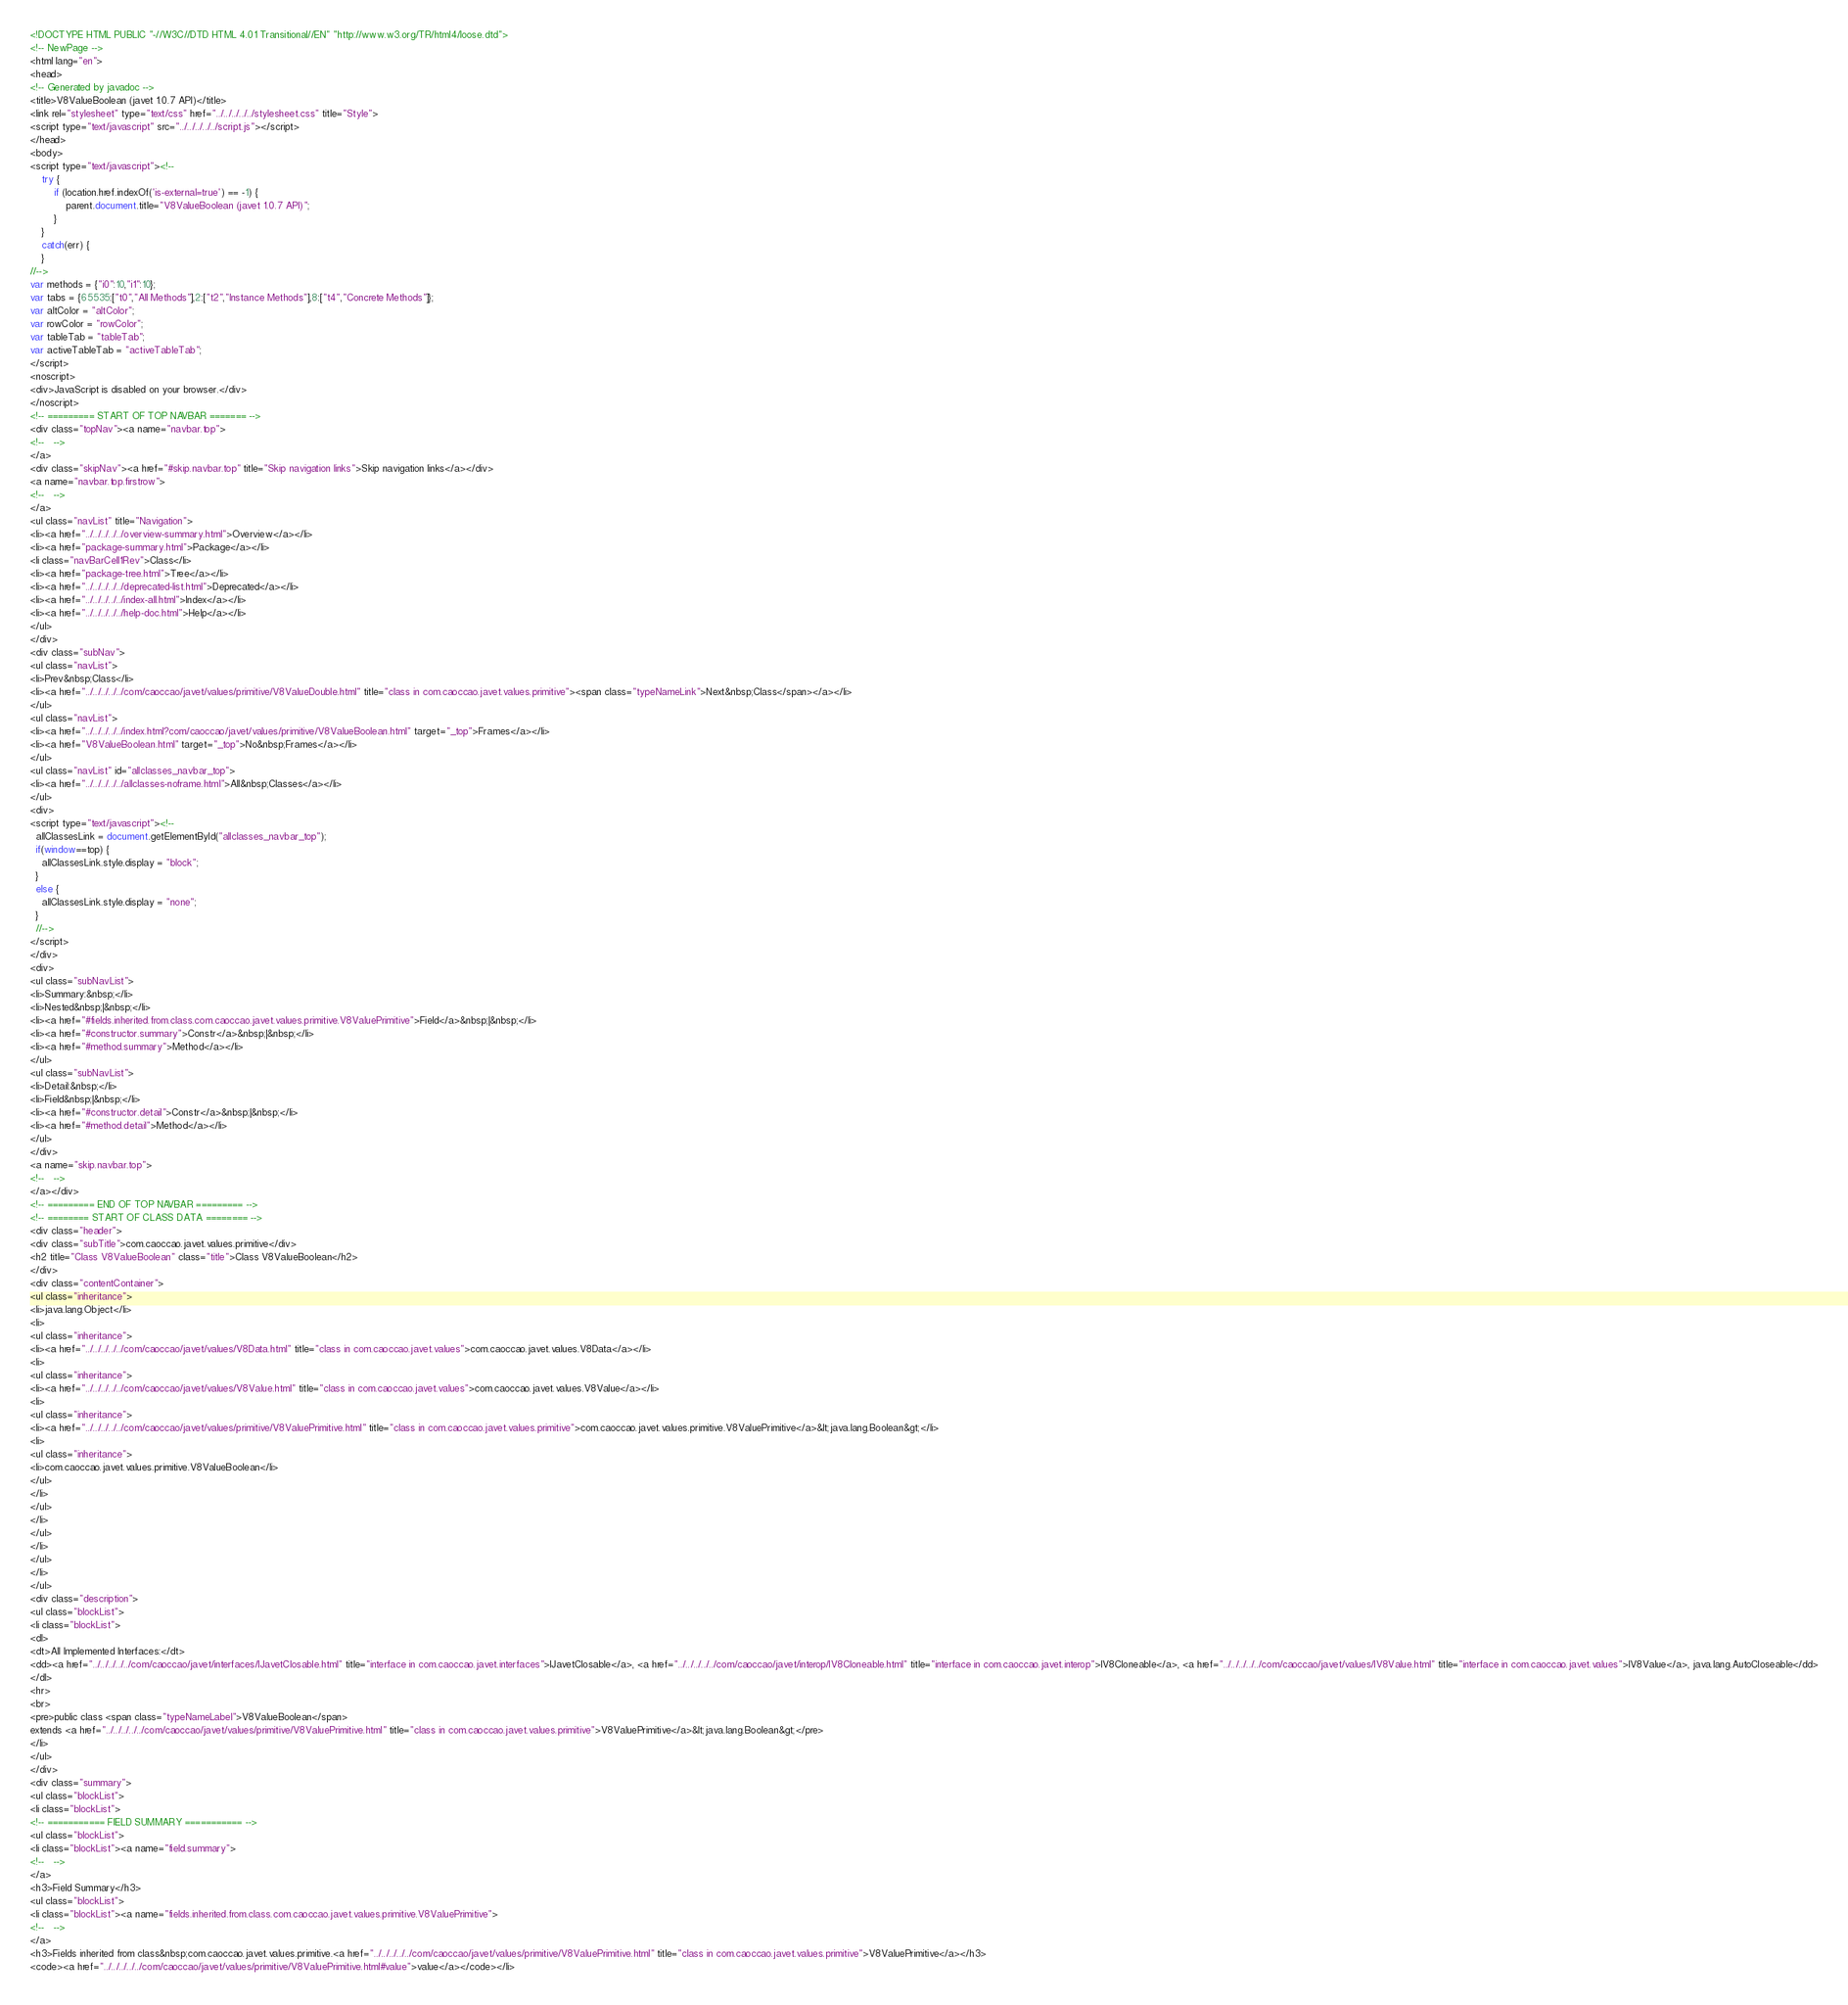Convert code to text. <code><loc_0><loc_0><loc_500><loc_500><_HTML_><!DOCTYPE HTML PUBLIC "-//W3C//DTD HTML 4.01 Transitional//EN" "http://www.w3.org/TR/html4/loose.dtd">
<!-- NewPage -->
<html lang="en">
<head>
<!-- Generated by javadoc -->
<title>V8ValueBoolean (javet 1.0.7 API)</title>
<link rel="stylesheet" type="text/css" href="../../../../../stylesheet.css" title="Style">
<script type="text/javascript" src="../../../../../script.js"></script>
</head>
<body>
<script type="text/javascript"><!--
    try {
        if (location.href.indexOf('is-external=true') == -1) {
            parent.document.title="V8ValueBoolean (javet 1.0.7 API)";
        }
    }
    catch(err) {
    }
//-->
var methods = {"i0":10,"i1":10};
var tabs = {65535:["t0","All Methods"],2:["t2","Instance Methods"],8:["t4","Concrete Methods"]};
var altColor = "altColor";
var rowColor = "rowColor";
var tableTab = "tableTab";
var activeTableTab = "activeTableTab";
</script>
<noscript>
<div>JavaScript is disabled on your browser.</div>
</noscript>
<!-- ========= START OF TOP NAVBAR ======= -->
<div class="topNav"><a name="navbar.top">
<!--   -->
</a>
<div class="skipNav"><a href="#skip.navbar.top" title="Skip navigation links">Skip navigation links</a></div>
<a name="navbar.top.firstrow">
<!--   -->
</a>
<ul class="navList" title="Navigation">
<li><a href="../../../../../overview-summary.html">Overview</a></li>
<li><a href="package-summary.html">Package</a></li>
<li class="navBarCell1Rev">Class</li>
<li><a href="package-tree.html">Tree</a></li>
<li><a href="../../../../../deprecated-list.html">Deprecated</a></li>
<li><a href="../../../../../index-all.html">Index</a></li>
<li><a href="../../../../../help-doc.html">Help</a></li>
</ul>
</div>
<div class="subNav">
<ul class="navList">
<li>Prev&nbsp;Class</li>
<li><a href="../../../../../com/caoccao/javet/values/primitive/V8ValueDouble.html" title="class in com.caoccao.javet.values.primitive"><span class="typeNameLink">Next&nbsp;Class</span></a></li>
</ul>
<ul class="navList">
<li><a href="../../../../../index.html?com/caoccao/javet/values/primitive/V8ValueBoolean.html" target="_top">Frames</a></li>
<li><a href="V8ValueBoolean.html" target="_top">No&nbsp;Frames</a></li>
</ul>
<ul class="navList" id="allclasses_navbar_top">
<li><a href="../../../../../allclasses-noframe.html">All&nbsp;Classes</a></li>
</ul>
<div>
<script type="text/javascript"><!--
  allClassesLink = document.getElementById("allclasses_navbar_top");
  if(window==top) {
    allClassesLink.style.display = "block";
  }
  else {
    allClassesLink.style.display = "none";
  }
  //-->
</script>
</div>
<div>
<ul class="subNavList">
<li>Summary:&nbsp;</li>
<li>Nested&nbsp;|&nbsp;</li>
<li><a href="#fields.inherited.from.class.com.caoccao.javet.values.primitive.V8ValuePrimitive">Field</a>&nbsp;|&nbsp;</li>
<li><a href="#constructor.summary">Constr</a>&nbsp;|&nbsp;</li>
<li><a href="#method.summary">Method</a></li>
</ul>
<ul class="subNavList">
<li>Detail:&nbsp;</li>
<li>Field&nbsp;|&nbsp;</li>
<li><a href="#constructor.detail">Constr</a>&nbsp;|&nbsp;</li>
<li><a href="#method.detail">Method</a></li>
</ul>
</div>
<a name="skip.navbar.top">
<!--   -->
</a></div>
<!-- ========= END OF TOP NAVBAR ========= -->
<!-- ======== START OF CLASS DATA ======== -->
<div class="header">
<div class="subTitle">com.caoccao.javet.values.primitive</div>
<h2 title="Class V8ValueBoolean" class="title">Class V8ValueBoolean</h2>
</div>
<div class="contentContainer">
<ul class="inheritance">
<li>java.lang.Object</li>
<li>
<ul class="inheritance">
<li><a href="../../../../../com/caoccao/javet/values/V8Data.html" title="class in com.caoccao.javet.values">com.caoccao.javet.values.V8Data</a></li>
<li>
<ul class="inheritance">
<li><a href="../../../../../com/caoccao/javet/values/V8Value.html" title="class in com.caoccao.javet.values">com.caoccao.javet.values.V8Value</a></li>
<li>
<ul class="inheritance">
<li><a href="../../../../../com/caoccao/javet/values/primitive/V8ValuePrimitive.html" title="class in com.caoccao.javet.values.primitive">com.caoccao.javet.values.primitive.V8ValuePrimitive</a>&lt;java.lang.Boolean&gt;</li>
<li>
<ul class="inheritance">
<li>com.caoccao.javet.values.primitive.V8ValueBoolean</li>
</ul>
</li>
</ul>
</li>
</ul>
</li>
</ul>
</li>
</ul>
<div class="description">
<ul class="blockList">
<li class="blockList">
<dl>
<dt>All Implemented Interfaces:</dt>
<dd><a href="../../../../../com/caoccao/javet/interfaces/IJavetClosable.html" title="interface in com.caoccao.javet.interfaces">IJavetClosable</a>, <a href="../../../../../com/caoccao/javet/interop/IV8Cloneable.html" title="interface in com.caoccao.javet.interop">IV8Cloneable</a>, <a href="../../../../../com/caoccao/javet/values/IV8Value.html" title="interface in com.caoccao.javet.values">IV8Value</a>, java.lang.AutoCloseable</dd>
</dl>
<hr>
<br>
<pre>public class <span class="typeNameLabel">V8ValueBoolean</span>
extends <a href="../../../../../com/caoccao/javet/values/primitive/V8ValuePrimitive.html" title="class in com.caoccao.javet.values.primitive">V8ValuePrimitive</a>&lt;java.lang.Boolean&gt;</pre>
</li>
</ul>
</div>
<div class="summary">
<ul class="blockList">
<li class="blockList">
<!-- =========== FIELD SUMMARY =========== -->
<ul class="blockList">
<li class="blockList"><a name="field.summary">
<!--   -->
</a>
<h3>Field Summary</h3>
<ul class="blockList">
<li class="blockList"><a name="fields.inherited.from.class.com.caoccao.javet.values.primitive.V8ValuePrimitive">
<!--   -->
</a>
<h3>Fields inherited from class&nbsp;com.caoccao.javet.values.primitive.<a href="../../../../../com/caoccao/javet/values/primitive/V8ValuePrimitive.html" title="class in com.caoccao.javet.values.primitive">V8ValuePrimitive</a></h3>
<code><a href="../../../../../com/caoccao/javet/values/primitive/V8ValuePrimitive.html#value">value</a></code></li></code> 